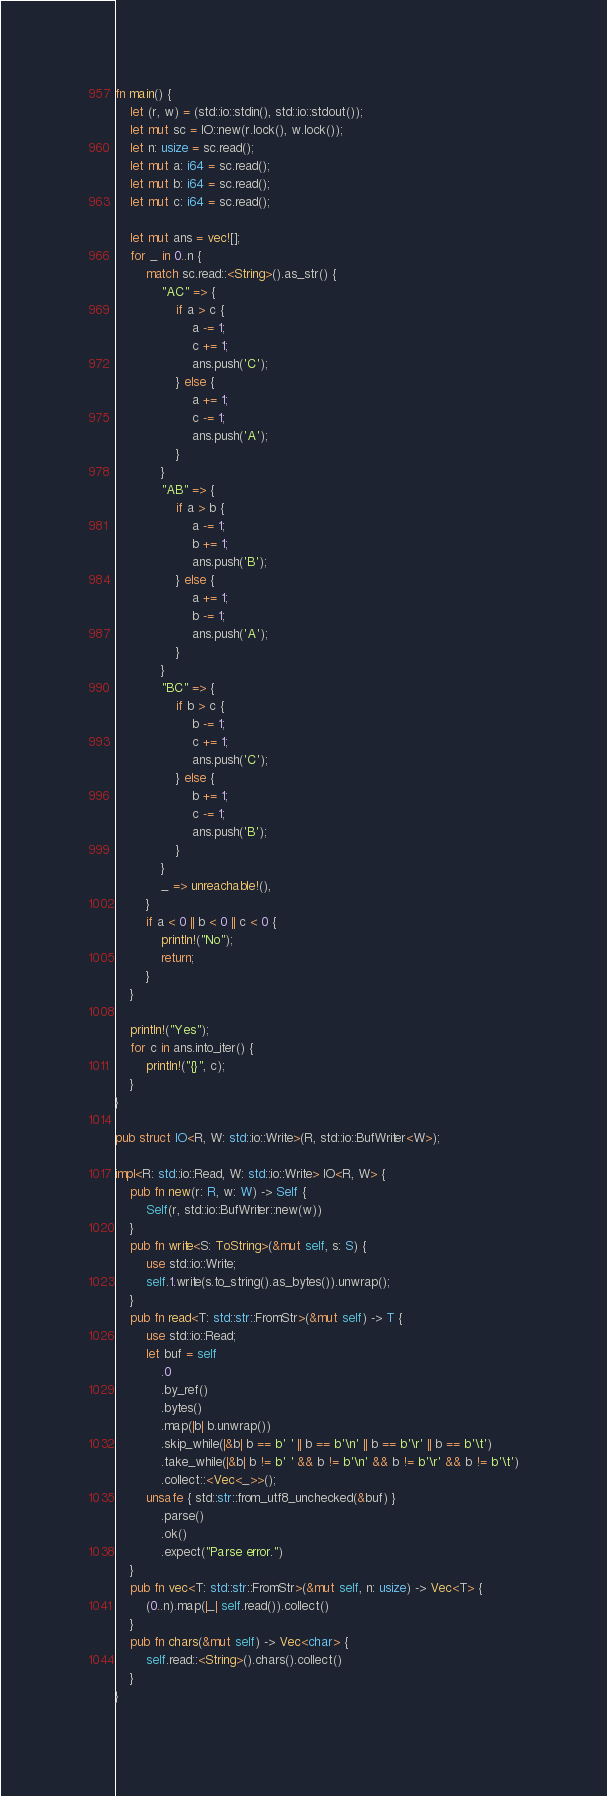<code> <loc_0><loc_0><loc_500><loc_500><_Rust_>fn main() {
    let (r, w) = (std::io::stdin(), std::io::stdout());
    let mut sc = IO::new(r.lock(), w.lock());
    let n: usize = sc.read();
    let mut a: i64 = sc.read();
    let mut b: i64 = sc.read();
    let mut c: i64 = sc.read();

    let mut ans = vec![];
    for _ in 0..n {
        match sc.read::<String>().as_str() {
            "AC" => {
                if a > c {
                    a -= 1;
                    c += 1;
                    ans.push('C');
                } else {
                    a += 1;
                    c -= 1;
                    ans.push('A');
                }
            }
            "AB" => {
                if a > b {
                    a -= 1;
                    b += 1;
                    ans.push('B');
                } else {
                    a += 1;
                    b -= 1;
                    ans.push('A');
                }
            }
            "BC" => {
                if b > c {
                    b -= 1;
                    c += 1;
                    ans.push('C');
                } else {
                    b += 1;
                    c -= 1;
                    ans.push('B');
                }
            }
            _ => unreachable!(),
        }
        if a < 0 || b < 0 || c < 0 {
            println!("No");
            return;
        }
    }

    println!("Yes");
    for c in ans.into_iter() {
        println!("{}", c);
    }
}

pub struct IO<R, W: std::io::Write>(R, std::io::BufWriter<W>);

impl<R: std::io::Read, W: std::io::Write> IO<R, W> {
    pub fn new(r: R, w: W) -> Self {
        Self(r, std::io::BufWriter::new(w))
    }
    pub fn write<S: ToString>(&mut self, s: S) {
        use std::io::Write;
        self.1.write(s.to_string().as_bytes()).unwrap();
    }
    pub fn read<T: std::str::FromStr>(&mut self) -> T {
        use std::io::Read;
        let buf = self
            .0
            .by_ref()
            .bytes()
            .map(|b| b.unwrap())
            .skip_while(|&b| b == b' ' || b == b'\n' || b == b'\r' || b == b'\t')
            .take_while(|&b| b != b' ' && b != b'\n' && b != b'\r' && b != b'\t')
            .collect::<Vec<_>>();
        unsafe { std::str::from_utf8_unchecked(&buf) }
            .parse()
            .ok()
            .expect("Parse error.")
    }
    pub fn vec<T: std::str::FromStr>(&mut self, n: usize) -> Vec<T> {
        (0..n).map(|_| self.read()).collect()
    }
    pub fn chars(&mut self) -> Vec<char> {
        self.read::<String>().chars().collect()
    }
}
</code> 